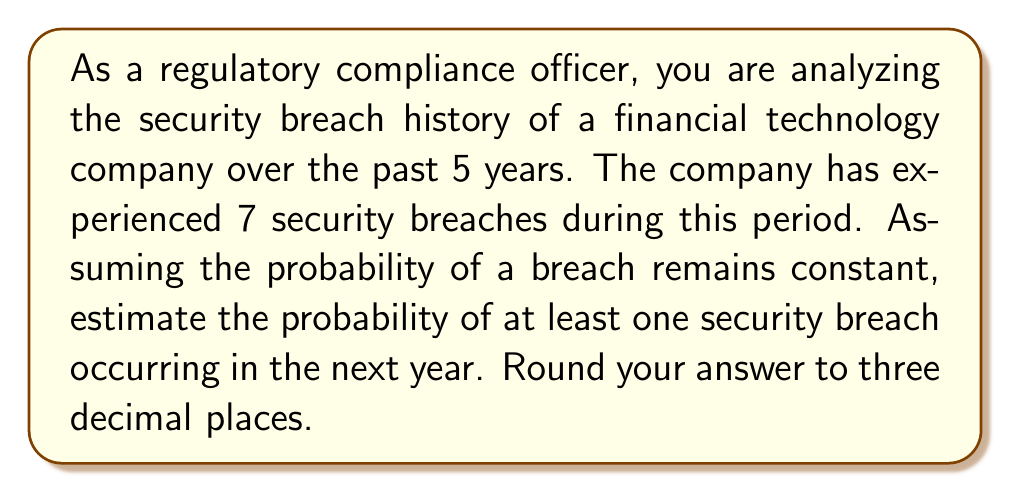What is the answer to this math problem? To solve this problem, we'll follow these steps:

1) First, let's calculate the average number of breaches per year:
   $$\text{Average breaches per year} = \frac{\text{Total breaches}}{\text{Number of years}} = \frac{7}{5} = 1.4$$

2) Now, we need to find the probability of at least one breach in the next year. It's often easier to calculate the probability of the complement event (no breaches) and then subtract from 1.

3) Assuming breaches follow a Poisson distribution (which is common for rare events), the probability of exactly k events in a given interval is:

   $$P(X = k) = \frac{e^{-\lambda}\lambda^k}{k!}$$

   where $\lambda$ is the average number of events per interval.

4) We want the probability of 0 breaches:

   $$P(X = 0) = \frac{e^{-1.4}(1.4)^0}{0!} = e^{-1.4} \approx 0.2466$$

5) The probability of at least one breach is the complement of this:

   $$P(\text{at least one breach}) = 1 - P(\text{no breaches}) = 1 - 0.2466 \approx 0.7534$$

6) Rounding to three decimal places: 0.753
Answer: 0.753 